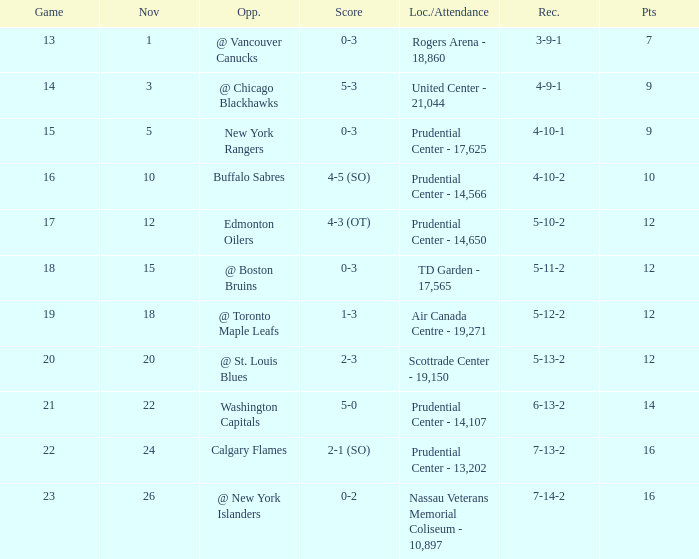What is the total number of locations that had a score of 1-3? 1.0. 